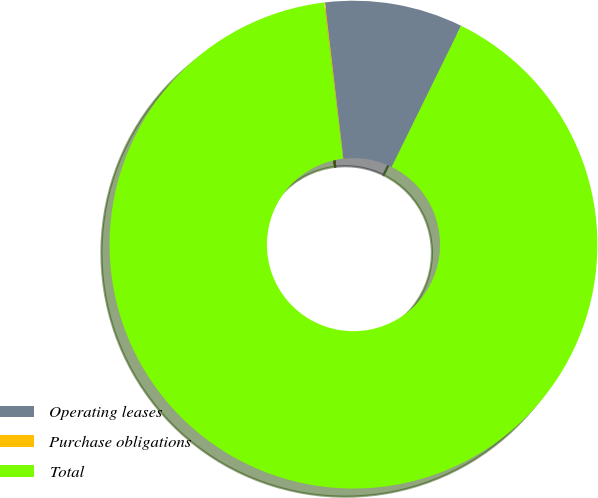Convert chart. <chart><loc_0><loc_0><loc_500><loc_500><pie_chart><fcel>Operating leases<fcel>Purchase obligations<fcel>Total<nl><fcel>9.14%<fcel>0.06%<fcel>90.8%<nl></chart> 